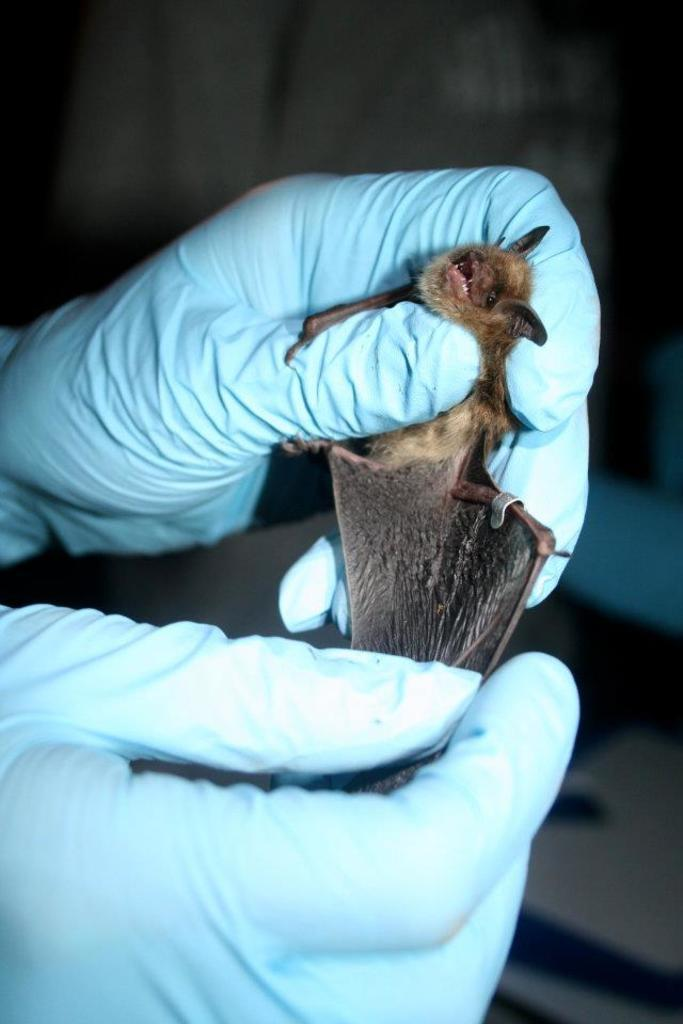What is located in the center of the image? There are hands in the center of the image. What are the hands wearing? The hands are wearing gloves. What are the hands holding? The hands are holding a bat. What can be observed about the background of the image? The background of the image is dark. What type of yoke can be seen in the image? There is no yoke present in the image. Can you describe the office setting in the image? There is no office setting present in the image. 